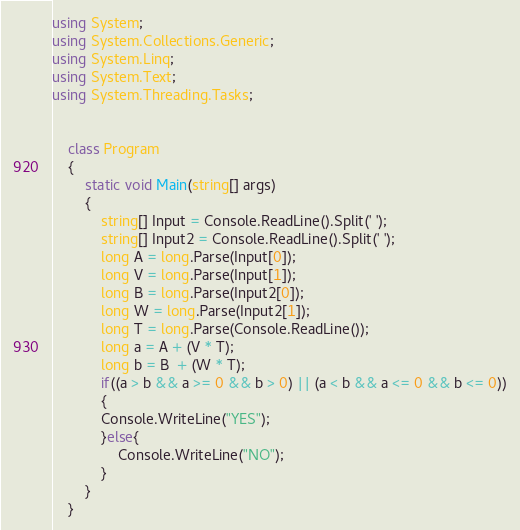<code> <loc_0><loc_0><loc_500><loc_500><_C#_>using System;
using System.Collections.Generic;
using System.Linq;
using System.Text;
using System.Threading.Tasks;


    class Program
    {
        static void Main(string[] args)
        {
            string[] Input = Console.ReadLine().Split(' ');
            string[] Input2 = Console.ReadLine().Split(' ');
            long A = long.Parse(Input[0]);
            long V = long.Parse(Input[1]);
            long B = long.Parse(Input2[0]);
            long W = long.Parse(Input2[1]);
            long T = long.Parse(Console.ReadLine());
            long a = A + (V * T);
            long b = B  + (W * T);
            if((a > b && a >= 0 && b > 0) || (a < b && a <= 0 && b <= 0))
            {
            Console.WriteLine("YES");
            }else{
                Console.WriteLine("NO");
            }
        }
    }</code> 